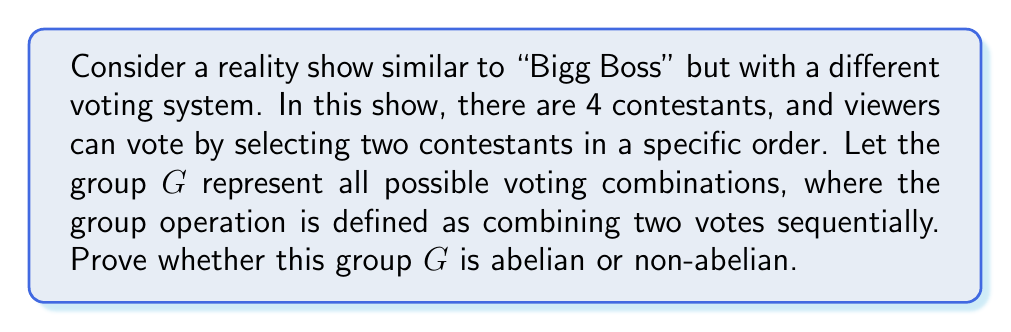Show me your answer to this math problem. Let's approach this step-by-step:

1) First, let's define our group elements. With 4 contestants (A, B, C, D), we have 12 possible voting combinations:
   $G = \{AB, AC, AD, BA, BC, BD, CA, CB, CD, DA, DB, DC\}$

2) The group operation is combining votes sequentially. For example:
   $AB * CD = ABCD$ (vote for AB, then vote for CD)

3) To determine if the group is abelian, we need to check if the operation is commutative for all elements. In other words, we need to verify if $a * b = b * a$ for all $a, b \in G$.

4) Let's take two arbitrary elements, say $AB$ and $CD$:
   $AB * CD = ABCD$
   $CD * AB = CDAB$

5) Clearly, $ABCD \neq CDAB$. This means that the order of operation matters, and thus the group operation is not commutative.

6) We only need one counterexample to prove that a group is non-abelian. Since we've found one, we can conclude that the group $G$ is non-abelian.

7) Intuitively, this makes sense in the context of a reality show. The order in which people vote can significantly impact the outcome, especially if voting trends influence later voters.
Answer: The group $G$ representing voting patterns in this reality show is non-abelian. 